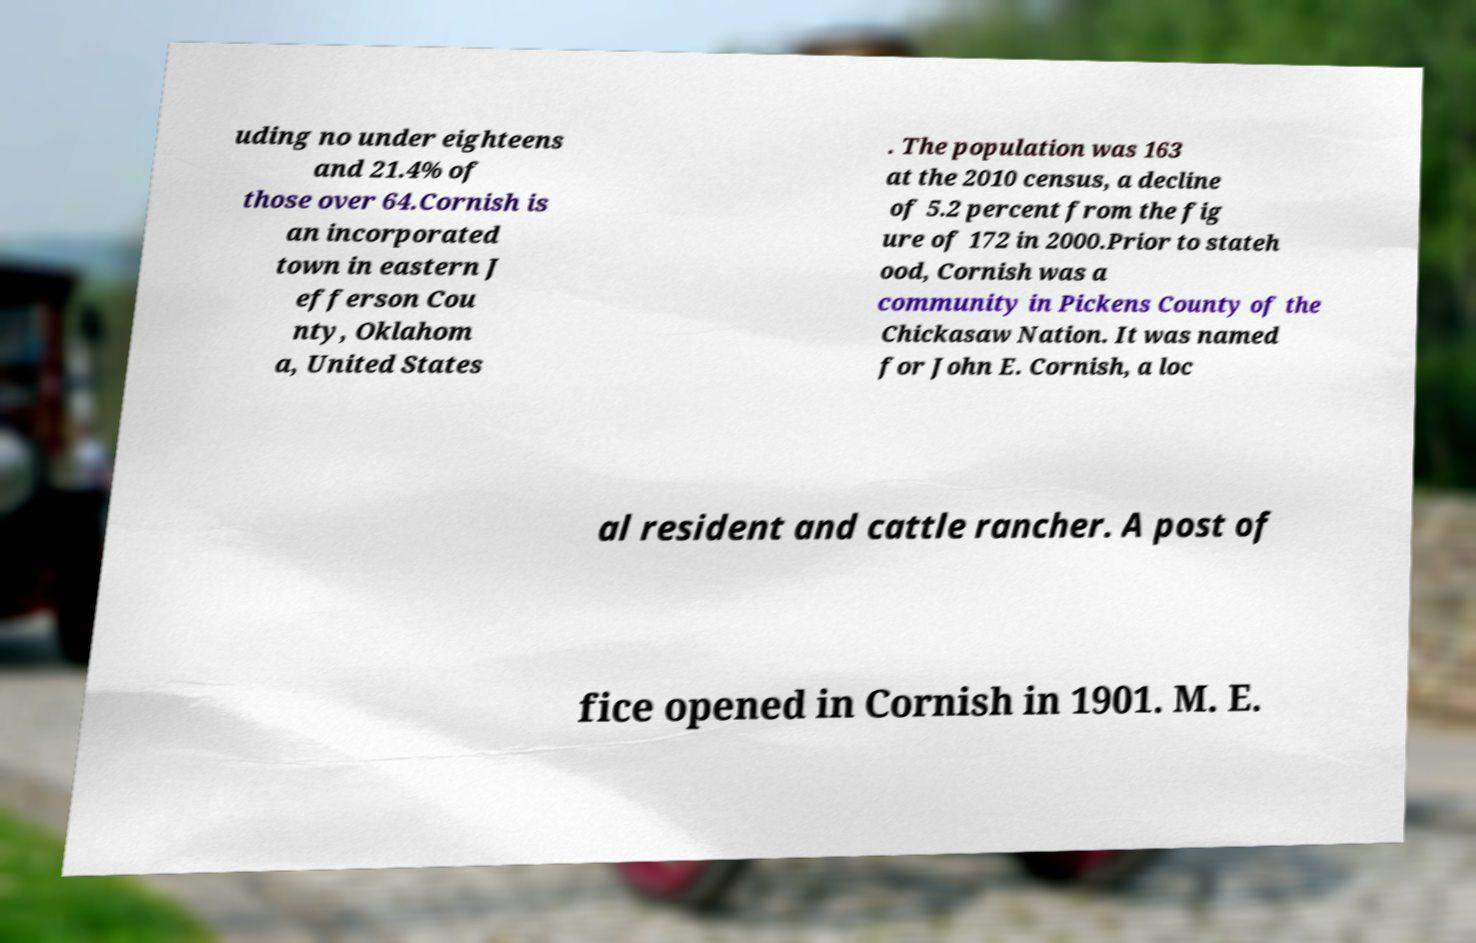Could you assist in decoding the text presented in this image and type it out clearly? uding no under eighteens and 21.4% of those over 64.Cornish is an incorporated town in eastern J efferson Cou nty, Oklahom a, United States . The population was 163 at the 2010 census, a decline of 5.2 percent from the fig ure of 172 in 2000.Prior to stateh ood, Cornish was a community in Pickens County of the Chickasaw Nation. It was named for John E. Cornish, a loc al resident and cattle rancher. A post of fice opened in Cornish in 1901. M. E. 